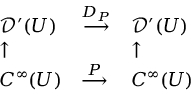Convert formula to latex. <formula><loc_0><loc_0><loc_500><loc_500>\begin{array} { l l l } { { \mathcal { D } } ^ { \prime } ( U ) } & { { \stackrel { D _ { P } } { \longrightarrow } } } & { { \mathcal { D } } ^ { \prime } ( U ) } \\ { \uparrow } & { \uparrow } \\ { C ^ { \infty } ( U ) } & { { \stackrel { P } { \longrightarrow } } } & { C ^ { \infty } ( U ) } \end{array}</formula> 